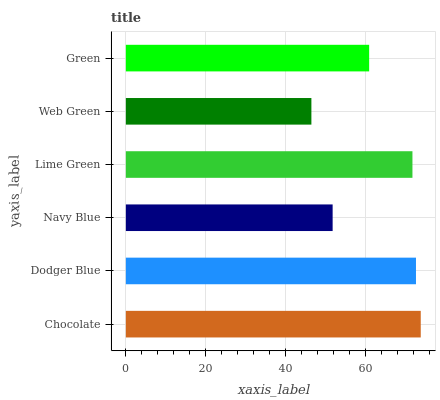Is Web Green the minimum?
Answer yes or no. Yes. Is Chocolate the maximum?
Answer yes or no. Yes. Is Dodger Blue the minimum?
Answer yes or no. No. Is Dodger Blue the maximum?
Answer yes or no. No. Is Chocolate greater than Dodger Blue?
Answer yes or no. Yes. Is Dodger Blue less than Chocolate?
Answer yes or no. Yes. Is Dodger Blue greater than Chocolate?
Answer yes or no. No. Is Chocolate less than Dodger Blue?
Answer yes or no. No. Is Lime Green the high median?
Answer yes or no. Yes. Is Green the low median?
Answer yes or no. Yes. Is Dodger Blue the high median?
Answer yes or no. No. Is Lime Green the low median?
Answer yes or no. No. 